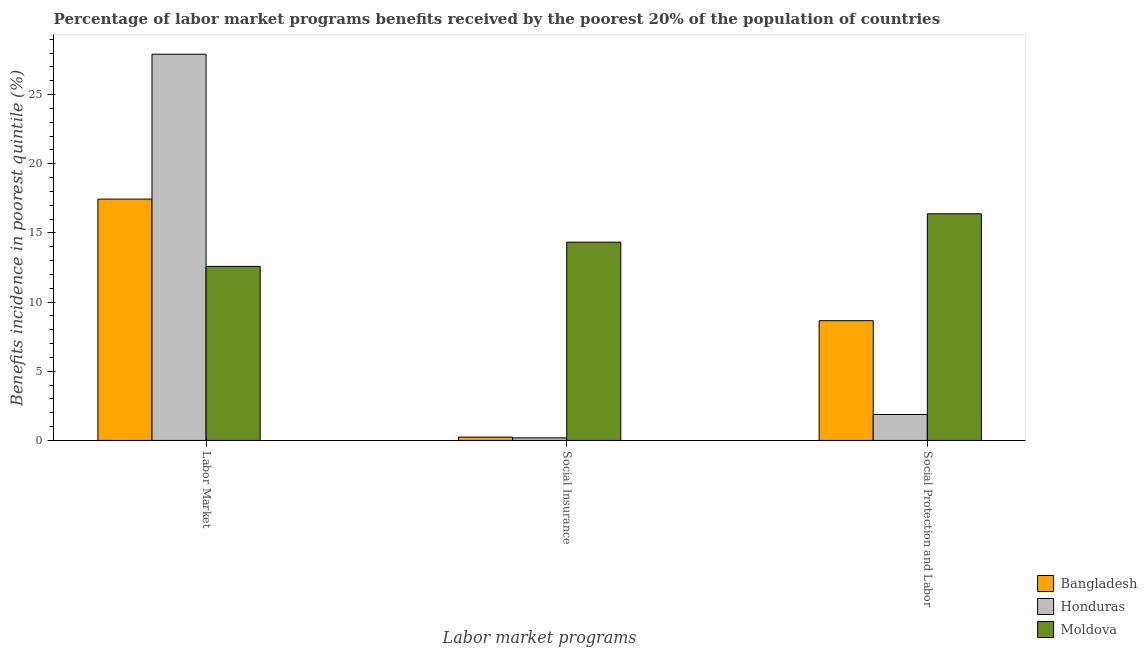How many different coloured bars are there?
Provide a succinct answer. 3. Are the number of bars per tick equal to the number of legend labels?
Your answer should be very brief. Yes. How many bars are there on the 2nd tick from the left?
Provide a short and direct response. 3. How many bars are there on the 2nd tick from the right?
Provide a succinct answer. 3. What is the label of the 1st group of bars from the left?
Keep it short and to the point. Labor Market. What is the percentage of benefits received due to social protection programs in Moldova?
Your response must be concise. 16.39. Across all countries, what is the maximum percentage of benefits received due to social insurance programs?
Keep it short and to the point. 14.33. Across all countries, what is the minimum percentage of benefits received due to social protection programs?
Give a very brief answer. 1.88. In which country was the percentage of benefits received due to labor market programs maximum?
Your response must be concise. Honduras. In which country was the percentage of benefits received due to social protection programs minimum?
Provide a succinct answer. Honduras. What is the total percentage of benefits received due to social protection programs in the graph?
Your answer should be very brief. 26.92. What is the difference between the percentage of benefits received due to social insurance programs in Bangladesh and that in Moldova?
Your answer should be compact. -14.09. What is the difference between the percentage of benefits received due to labor market programs in Bangladesh and the percentage of benefits received due to social protection programs in Moldova?
Make the answer very short. 1.06. What is the average percentage of benefits received due to social insurance programs per country?
Ensure brevity in your answer.  4.92. What is the difference between the percentage of benefits received due to labor market programs and percentage of benefits received due to social protection programs in Bangladesh?
Your response must be concise. 8.79. What is the ratio of the percentage of benefits received due to social protection programs in Moldova to that in Bangladesh?
Make the answer very short. 1.89. Is the percentage of benefits received due to social insurance programs in Honduras less than that in Moldova?
Keep it short and to the point. Yes. What is the difference between the highest and the second highest percentage of benefits received due to social insurance programs?
Provide a short and direct response. 14.09. What is the difference between the highest and the lowest percentage of benefits received due to labor market programs?
Make the answer very short. 15.34. What does the 3rd bar from the left in Labor Market represents?
Your answer should be very brief. Moldova. What does the 2nd bar from the right in Social Insurance represents?
Provide a succinct answer. Honduras. Is it the case that in every country, the sum of the percentage of benefits received due to labor market programs and percentage of benefits received due to social insurance programs is greater than the percentage of benefits received due to social protection programs?
Keep it short and to the point. Yes. How many bars are there?
Your answer should be compact. 9. What is the difference between two consecutive major ticks on the Y-axis?
Your answer should be very brief. 5. Are the values on the major ticks of Y-axis written in scientific E-notation?
Offer a very short reply. No. Does the graph contain any zero values?
Offer a terse response. No. Where does the legend appear in the graph?
Your answer should be very brief. Bottom right. What is the title of the graph?
Offer a very short reply. Percentage of labor market programs benefits received by the poorest 20% of the population of countries. Does "St. Lucia" appear as one of the legend labels in the graph?
Provide a short and direct response. No. What is the label or title of the X-axis?
Offer a very short reply. Labor market programs. What is the label or title of the Y-axis?
Your answer should be very brief. Benefits incidence in poorest quintile (%). What is the Benefits incidence in poorest quintile (%) in Bangladesh in Labor Market?
Keep it short and to the point. 17.45. What is the Benefits incidence in poorest quintile (%) in Honduras in Labor Market?
Keep it short and to the point. 27.92. What is the Benefits incidence in poorest quintile (%) in Moldova in Labor Market?
Ensure brevity in your answer.  12.58. What is the Benefits incidence in poorest quintile (%) in Bangladesh in Social Insurance?
Your response must be concise. 0.24. What is the Benefits incidence in poorest quintile (%) of Honduras in Social Insurance?
Your answer should be compact. 0.19. What is the Benefits incidence in poorest quintile (%) of Moldova in Social Insurance?
Your answer should be very brief. 14.33. What is the Benefits incidence in poorest quintile (%) in Bangladesh in Social Protection and Labor?
Offer a terse response. 8.66. What is the Benefits incidence in poorest quintile (%) of Honduras in Social Protection and Labor?
Make the answer very short. 1.88. What is the Benefits incidence in poorest quintile (%) in Moldova in Social Protection and Labor?
Provide a succinct answer. 16.39. Across all Labor market programs, what is the maximum Benefits incidence in poorest quintile (%) of Bangladesh?
Your response must be concise. 17.45. Across all Labor market programs, what is the maximum Benefits incidence in poorest quintile (%) in Honduras?
Your answer should be very brief. 27.92. Across all Labor market programs, what is the maximum Benefits incidence in poorest quintile (%) of Moldova?
Provide a short and direct response. 16.39. Across all Labor market programs, what is the minimum Benefits incidence in poorest quintile (%) in Bangladesh?
Give a very brief answer. 0.24. Across all Labor market programs, what is the minimum Benefits incidence in poorest quintile (%) of Honduras?
Your answer should be compact. 0.19. Across all Labor market programs, what is the minimum Benefits incidence in poorest quintile (%) in Moldova?
Your answer should be compact. 12.58. What is the total Benefits incidence in poorest quintile (%) in Bangladesh in the graph?
Give a very brief answer. 26.35. What is the total Benefits incidence in poorest quintile (%) in Honduras in the graph?
Make the answer very short. 29.98. What is the total Benefits incidence in poorest quintile (%) in Moldova in the graph?
Your answer should be very brief. 43.3. What is the difference between the Benefits incidence in poorest quintile (%) of Bangladesh in Labor Market and that in Social Insurance?
Give a very brief answer. 17.21. What is the difference between the Benefits incidence in poorest quintile (%) in Honduras in Labor Market and that in Social Insurance?
Offer a terse response. 27.74. What is the difference between the Benefits incidence in poorest quintile (%) of Moldova in Labor Market and that in Social Insurance?
Offer a terse response. -1.75. What is the difference between the Benefits incidence in poorest quintile (%) in Bangladesh in Labor Market and that in Social Protection and Labor?
Your response must be concise. 8.79. What is the difference between the Benefits incidence in poorest quintile (%) of Honduras in Labor Market and that in Social Protection and Labor?
Ensure brevity in your answer.  26.05. What is the difference between the Benefits incidence in poorest quintile (%) in Moldova in Labor Market and that in Social Protection and Labor?
Provide a short and direct response. -3.8. What is the difference between the Benefits incidence in poorest quintile (%) of Bangladesh in Social Insurance and that in Social Protection and Labor?
Offer a terse response. -8.42. What is the difference between the Benefits incidence in poorest quintile (%) of Honduras in Social Insurance and that in Social Protection and Labor?
Give a very brief answer. -1.69. What is the difference between the Benefits incidence in poorest quintile (%) of Moldova in Social Insurance and that in Social Protection and Labor?
Keep it short and to the point. -2.05. What is the difference between the Benefits incidence in poorest quintile (%) in Bangladesh in Labor Market and the Benefits incidence in poorest quintile (%) in Honduras in Social Insurance?
Provide a succinct answer. 17.26. What is the difference between the Benefits incidence in poorest quintile (%) in Bangladesh in Labor Market and the Benefits incidence in poorest quintile (%) in Moldova in Social Insurance?
Provide a short and direct response. 3.11. What is the difference between the Benefits incidence in poorest quintile (%) in Honduras in Labor Market and the Benefits incidence in poorest quintile (%) in Moldova in Social Insurance?
Offer a very short reply. 13.59. What is the difference between the Benefits incidence in poorest quintile (%) of Bangladesh in Labor Market and the Benefits incidence in poorest quintile (%) of Honduras in Social Protection and Labor?
Make the answer very short. 15.57. What is the difference between the Benefits incidence in poorest quintile (%) of Bangladesh in Labor Market and the Benefits incidence in poorest quintile (%) of Moldova in Social Protection and Labor?
Make the answer very short. 1.06. What is the difference between the Benefits incidence in poorest quintile (%) in Honduras in Labor Market and the Benefits incidence in poorest quintile (%) in Moldova in Social Protection and Labor?
Provide a short and direct response. 11.54. What is the difference between the Benefits incidence in poorest quintile (%) of Bangladesh in Social Insurance and the Benefits incidence in poorest quintile (%) of Honduras in Social Protection and Labor?
Ensure brevity in your answer.  -1.63. What is the difference between the Benefits incidence in poorest quintile (%) of Bangladesh in Social Insurance and the Benefits incidence in poorest quintile (%) of Moldova in Social Protection and Labor?
Your answer should be compact. -16.15. What is the difference between the Benefits incidence in poorest quintile (%) of Honduras in Social Insurance and the Benefits incidence in poorest quintile (%) of Moldova in Social Protection and Labor?
Keep it short and to the point. -16.2. What is the average Benefits incidence in poorest quintile (%) in Bangladesh per Labor market programs?
Offer a terse response. 8.78. What is the average Benefits incidence in poorest quintile (%) of Honduras per Labor market programs?
Your response must be concise. 9.99. What is the average Benefits incidence in poorest quintile (%) in Moldova per Labor market programs?
Provide a short and direct response. 14.44. What is the difference between the Benefits incidence in poorest quintile (%) of Bangladesh and Benefits incidence in poorest quintile (%) of Honduras in Labor Market?
Give a very brief answer. -10.48. What is the difference between the Benefits incidence in poorest quintile (%) of Bangladesh and Benefits incidence in poorest quintile (%) of Moldova in Labor Market?
Provide a succinct answer. 4.86. What is the difference between the Benefits incidence in poorest quintile (%) in Honduras and Benefits incidence in poorest quintile (%) in Moldova in Labor Market?
Make the answer very short. 15.34. What is the difference between the Benefits incidence in poorest quintile (%) of Bangladesh and Benefits incidence in poorest quintile (%) of Honduras in Social Insurance?
Your answer should be very brief. 0.06. What is the difference between the Benefits incidence in poorest quintile (%) of Bangladesh and Benefits incidence in poorest quintile (%) of Moldova in Social Insurance?
Your answer should be compact. -14.09. What is the difference between the Benefits incidence in poorest quintile (%) of Honduras and Benefits incidence in poorest quintile (%) of Moldova in Social Insurance?
Your answer should be very brief. -14.15. What is the difference between the Benefits incidence in poorest quintile (%) in Bangladesh and Benefits incidence in poorest quintile (%) in Honduras in Social Protection and Labor?
Provide a short and direct response. 6.78. What is the difference between the Benefits incidence in poorest quintile (%) in Bangladesh and Benefits incidence in poorest quintile (%) in Moldova in Social Protection and Labor?
Make the answer very short. -7.73. What is the difference between the Benefits incidence in poorest quintile (%) in Honduras and Benefits incidence in poorest quintile (%) in Moldova in Social Protection and Labor?
Provide a succinct answer. -14.51. What is the ratio of the Benefits incidence in poorest quintile (%) of Bangladesh in Labor Market to that in Social Insurance?
Make the answer very short. 72.09. What is the ratio of the Benefits incidence in poorest quintile (%) in Honduras in Labor Market to that in Social Insurance?
Offer a very short reply. 150.89. What is the ratio of the Benefits incidence in poorest quintile (%) of Moldova in Labor Market to that in Social Insurance?
Offer a terse response. 0.88. What is the ratio of the Benefits incidence in poorest quintile (%) of Bangladesh in Labor Market to that in Social Protection and Labor?
Your response must be concise. 2.02. What is the ratio of the Benefits incidence in poorest quintile (%) of Honduras in Labor Market to that in Social Protection and Labor?
Your answer should be compact. 14.88. What is the ratio of the Benefits incidence in poorest quintile (%) of Moldova in Labor Market to that in Social Protection and Labor?
Offer a terse response. 0.77. What is the ratio of the Benefits incidence in poorest quintile (%) in Bangladesh in Social Insurance to that in Social Protection and Labor?
Your answer should be compact. 0.03. What is the ratio of the Benefits incidence in poorest quintile (%) in Honduras in Social Insurance to that in Social Protection and Labor?
Your response must be concise. 0.1. What is the ratio of the Benefits incidence in poorest quintile (%) of Moldova in Social Insurance to that in Social Protection and Labor?
Ensure brevity in your answer.  0.87. What is the difference between the highest and the second highest Benefits incidence in poorest quintile (%) of Bangladesh?
Provide a short and direct response. 8.79. What is the difference between the highest and the second highest Benefits incidence in poorest quintile (%) of Honduras?
Give a very brief answer. 26.05. What is the difference between the highest and the second highest Benefits incidence in poorest quintile (%) of Moldova?
Offer a terse response. 2.05. What is the difference between the highest and the lowest Benefits incidence in poorest quintile (%) of Bangladesh?
Provide a succinct answer. 17.21. What is the difference between the highest and the lowest Benefits incidence in poorest quintile (%) of Honduras?
Make the answer very short. 27.74. What is the difference between the highest and the lowest Benefits incidence in poorest quintile (%) in Moldova?
Offer a terse response. 3.8. 